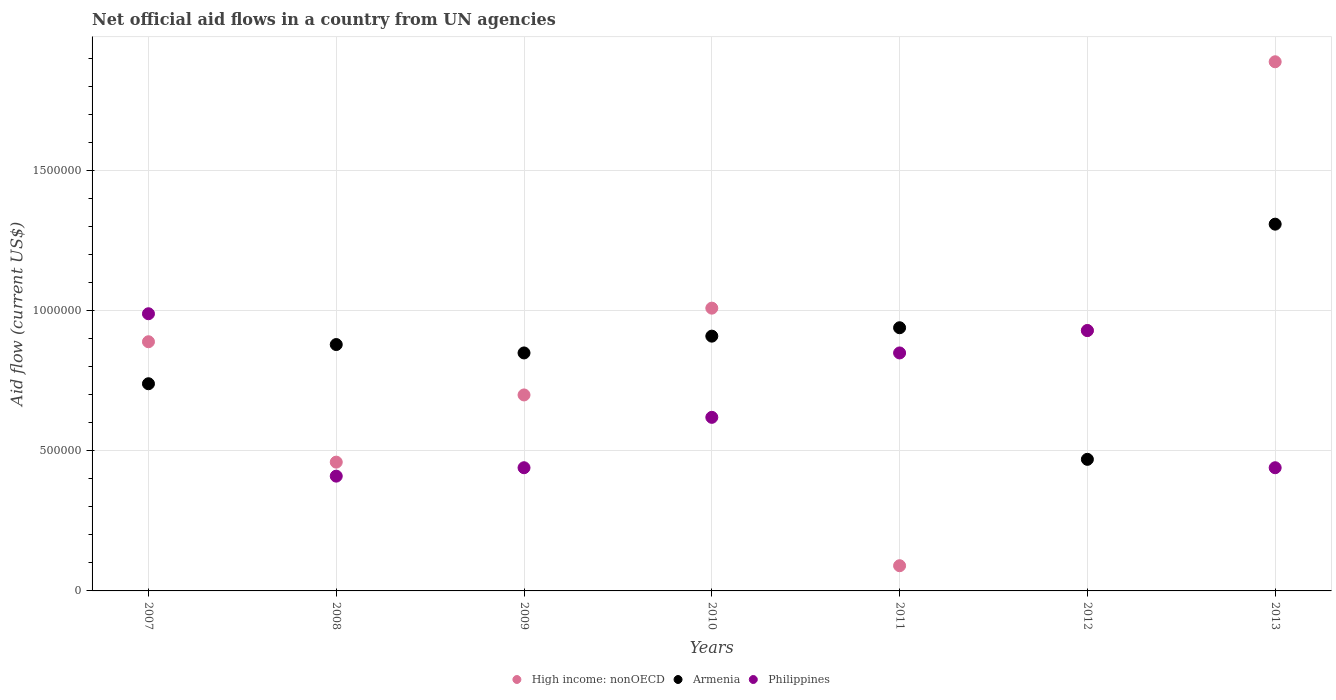How many different coloured dotlines are there?
Keep it short and to the point. 3. What is the net official aid flow in Armenia in 2009?
Give a very brief answer. 8.50e+05. Across all years, what is the maximum net official aid flow in Armenia?
Provide a succinct answer. 1.31e+06. Across all years, what is the minimum net official aid flow in High income: nonOECD?
Your response must be concise. 9.00e+04. In which year was the net official aid flow in Armenia minimum?
Provide a short and direct response. 2012. What is the total net official aid flow in High income: nonOECD in the graph?
Make the answer very short. 5.97e+06. What is the difference between the net official aid flow in Armenia in 2010 and that in 2013?
Your answer should be very brief. -4.00e+05. What is the difference between the net official aid flow in Philippines in 2011 and the net official aid flow in High income: nonOECD in 2009?
Provide a succinct answer. 1.50e+05. What is the average net official aid flow in High income: nonOECD per year?
Provide a short and direct response. 8.53e+05. In the year 2012, what is the difference between the net official aid flow in Philippines and net official aid flow in High income: nonOECD?
Your answer should be very brief. 0. What is the ratio of the net official aid flow in Philippines in 2008 to that in 2010?
Offer a terse response. 0.66. What is the difference between the highest and the second highest net official aid flow in Philippines?
Your answer should be compact. 6.00e+04. What is the difference between the highest and the lowest net official aid flow in High income: nonOECD?
Offer a terse response. 1.80e+06. In how many years, is the net official aid flow in Armenia greater than the average net official aid flow in Armenia taken over all years?
Provide a short and direct response. 4. Is the sum of the net official aid flow in High income: nonOECD in 2009 and 2010 greater than the maximum net official aid flow in Armenia across all years?
Offer a terse response. Yes. Is it the case that in every year, the sum of the net official aid flow in High income: nonOECD and net official aid flow in Philippines  is greater than the net official aid flow in Armenia?
Offer a very short reply. No. Is the net official aid flow in High income: nonOECD strictly greater than the net official aid flow in Armenia over the years?
Make the answer very short. No. Is the net official aid flow in High income: nonOECD strictly less than the net official aid flow in Philippines over the years?
Give a very brief answer. No. How many dotlines are there?
Your response must be concise. 3. What is the difference between two consecutive major ticks on the Y-axis?
Your response must be concise. 5.00e+05. Does the graph contain any zero values?
Ensure brevity in your answer.  No. Does the graph contain grids?
Your answer should be compact. Yes. Where does the legend appear in the graph?
Your answer should be compact. Bottom center. What is the title of the graph?
Provide a succinct answer. Net official aid flows in a country from UN agencies. Does "Macao" appear as one of the legend labels in the graph?
Offer a very short reply. No. What is the label or title of the X-axis?
Your response must be concise. Years. What is the label or title of the Y-axis?
Offer a terse response. Aid flow (current US$). What is the Aid flow (current US$) in High income: nonOECD in 2007?
Your answer should be very brief. 8.90e+05. What is the Aid flow (current US$) in Armenia in 2007?
Your answer should be very brief. 7.40e+05. What is the Aid flow (current US$) of Philippines in 2007?
Ensure brevity in your answer.  9.90e+05. What is the Aid flow (current US$) in Armenia in 2008?
Your answer should be compact. 8.80e+05. What is the Aid flow (current US$) of High income: nonOECD in 2009?
Your answer should be very brief. 7.00e+05. What is the Aid flow (current US$) of Armenia in 2009?
Offer a terse response. 8.50e+05. What is the Aid flow (current US$) in High income: nonOECD in 2010?
Keep it short and to the point. 1.01e+06. What is the Aid flow (current US$) of Armenia in 2010?
Your answer should be very brief. 9.10e+05. What is the Aid flow (current US$) of Philippines in 2010?
Provide a succinct answer. 6.20e+05. What is the Aid flow (current US$) in Armenia in 2011?
Keep it short and to the point. 9.40e+05. What is the Aid flow (current US$) of Philippines in 2011?
Make the answer very short. 8.50e+05. What is the Aid flow (current US$) in High income: nonOECD in 2012?
Provide a short and direct response. 9.30e+05. What is the Aid flow (current US$) in Philippines in 2012?
Provide a short and direct response. 9.30e+05. What is the Aid flow (current US$) in High income: nonOECD in 2013?
Provide a succinct answer. 1.89e+06. What is the Aid flow (current US$) in Armenia in 2013?
Keep it short and to the point. 1.31e+06. Across all years, what is the maximum Aid flow (current US$) in High income: nonOECD?
Provide a short and direct response. 1.89e+06. Across all years, what is the maximum Aid flow (current US$) of Armenia?
Offer a terse response. 1.31e+06. Across all years, what is the maximum Aid flow (current US$) in Philippines?
Your response must be concise. 9.90e+05. Across all years, what is the minimum Aid flow (current US$) of High income: nonOECD?
Offer a very short reply. 9.00e+04. Across all years, what is the minimum Aid flow (current US$) of Armenia?
Provide a succinct answer. 4.70e+05. Across all years, what is the minimum Aid flow (current US$) in Philippines?
Ensure brevity in your answer.  4.10e+05. What is the total Aid flow (current US$) of High income: nonOECD in the graph?
Make the answer very short. 5.97e+06. What is the total Aid flow (current US$) in Armenia in the graph?
Your response must be concise. 6.10e+06. What is the total Aid flow (current US$) of Philippines in the graph?
Ensure brevity in your answer.  4.68e+06. What is the difference between the Aid flow (current US$) in Philippines in 2007 and that in 2008?
Make the answer very short. 5.80e+05. What is the difference between the Aid flow (current US$) in Philippines in 2007 and that in 2009?
Make the answer very short. 5.50e+05. What is the difference between the Aid flow (current US$) of High income: nonOECD in 2007 and that in 2010?
Your answer should be compact. -1.20e+05. What is the difference between the Aid flow (current US$) in High income: nonOECD in 2007 and that in 2011?
Your response must be concise. 8.00e+05. What is the difference between the Aid flow (current US$) of Armenia in 2007 and that in 2012?
Make the answer very short. 2.70e+05. What is the difference between the Aid flow (current US$) of Philippines in 2007 and that in 2012?
Offer a terse response. 6.00e+04. What is the difference between the Aid flow (current US$) of Armenia in 2007 and that in 2013?
Give a very brief answer. -5.70e+05. What is the difference between the Aid flow (current US$) in Armenia in 2008 and that in 2009?
Provide a short and direct response. 3.00e+04. What is the difference between the Aid flow (current US$) of Philippines in 2008 and that in 2009?
Provide a short and direct response. -3.00e+04. What is the difference between the Aid flow (current US$) in High income: nonOECD in 2008 and that in 2010?
Offer a terse response. -5.50e+05. What is the difference between the Aid flow (current US$) of Armenia in 2008 and that in 2010?
Give a very brief answer. -3.00e+04. What is the difference between the Aid flow (current US$) in Philippines in 2008 and that in 2010?
Your response must be concise. -2.10e+05. What is the difference between the Aid flow (current US$) in Armenia in 2008 and that in 2011?
Your response must be concise. -6.00e+04. What is the difference between the Aid flow (current US$) of Philippines in 2008 and that in 2011?
Offer a terse response. -4.40e+05. What is the difference between the Aid flow (current US$) in High income: nonOECD in 2008 and that in 2012?
Give a very brief answer. -4.70e+05. What is the difference between the Aid flow (current US$) in Philippines in 2008 and that in 2012?
Provide a short and direct response. -5.20e+05. What is the difference between the Aid flow (current US$) of High income: nonOECD in 2008 and that in 2013?
Your answer should be very brief. -1.43e+06. What is the difference between the Aid flow (current US$) in Armenia in 2008 and that in 2013?
Make the answer very short. -4.30e+05. What is the difference between the Aid flow (current US$) of Philippines in 2008 and that in 2013?
Offer a terse response. -3.00e+04. What is the difference between the Aid flow (current US$) in High income: nonOECD in 2009 and that in 2010?
Provide a succinct answer. -3.10e+05. What is the difference between the Aid flow (current US$) in Armenia in 2009 and that in 2011?
Give a very brief answer. -9.00e+04. What is the difference between the Aid flow (current US$) in Philippines in 2009 and that in 2011?
Provide a short and direct response. -4.10e+05. What is the difference between the Aid flow (current US$) of High income: nonOECD in 2009 and that in 2012?
Make the answer very short. -2.30e+05. What is the difference between the Aid flow (current US$) of Armenia in 2009 and that in 2012?
Your response must be concise. 3.80e+05. What is the difference between the Aid flow (current US$) in Philippines in 2009 and that in 2012?
Provide a short and direct response. -4.90e+05. What is the difference between the Aid flow (current US$) in High income: nonOECD in 2009 and that in 2013?
Make the answer very short. -1.19e+06. What is the difference between the Aid flow (current US$) of Armenia in 2009 and that in 2013?
Your answer should be very brief. -4.60e+05. What is the difference between the Aid flow (current US$) of Philippines in 2009 and that in 2013?
Your answer should be very brief. 0. What is the difference between the Aid flow (current US$) of High income: nonOECD in 2010 and that in 2011?
Ensure brevity in your answer.  9.20e+05. What is the difference between the Aid flow (current US$) in Armenia in 2010 and that in 2011?
Provide a short and direct response. -3.00e+04. What is the difference between the Aid flow (current US$) of Philippines in 2010 and that in 2011?
Keep it short and to the point. -2.30e+05. What is the difference between the Aid flow (current US$) in High income: nonOECD in 2010 and that in 2012?
Your response must be concise. 8.00e+04. What is the difference between the Aid flow (current US$) in Philippines in 2010 and that in 2012?
Provide a succinct answer. -3.10e+05. What is the difference between the Aid flow (current US$) in High income: nonOECD in 2010 and that in 2013?
Provide a short and direct response. -8.80e+05. What is the difference between the Aid flow (current US$) of Armenia in 2010 and that in 2013?
Offer a terse response. -4.00e+05. What is the difference between the Aid flow (current US$) in Philippines in 2010 and that in 2013?
Provide a succinct answer. 1.80e+05. What is the difference between the Aid flow (current US$) of High income: nonOECD in 2011 and that in 2012?
Your answer should be compact. -8.40e+05. What is the difference between the Aid flow (current US$) of Armenia in 2011 and that in 2012?
Give a very brief answer. 4.70e+05. What is the difference between the Aid flow (current US$) of High income: nonOECD in 2011 and that in 2013?
Ensure brevity in your answer.  -1.80e+06. What is the difference between the Aid flow (current US$) in Armenia in 2011 and that in 2013?
Ensure brevity in your answer.  -3.70e+05. What is the difference between the Aid flow (current US$) of High income: nonOECD in 2012 and that in 2013?
Provide a short and direct response. -9.60e+05. What is the difference between the Aid flow (current US$) in Armenia in 2012 and that in 2013?
Your response must be concise. -8.40e+05. What is the difference between the Aid flow (current US$) of Armenia in 2007 and the Aid flow (current US$) of Philippines in 2008?
Keep it short and to the point. 3.30e+05. What is the difference between the Aid flow (current US$) of High income: nonOECD in 2007 and the Aid flow (current US$) of Armenia in 2009?
Provide a succinct answer. 4.00e+04. What is the difference between the Aid flow (current US$) in High income: nonOECD in 2007 and the Aid flow (current US$) in Philippines in 2009?
Your response must be concise. 4.50e+05. What is the difference between the Aid flow (current US$) of Armenia in 2007 and the Aid flow (current US$) of Philippines in 2009?
Ensure brevity in your answer.  3.00e+05. What is the difference between the Aid flow (current US$) of High income: nonOECD in 2007 and the Aid flow (current US$) of Armenia in 2010?
Offer a very short reply. -2.00e+04. What is the difference between the Aid flow (current US$) in High income: nonOECD in 2007 and the Aid flow (current US$) in Philippines in 2010?
Keep it short and to the point. 2.70e+05. What is the difference between the Aid flow (current US$) of Armenia in 2007 and the Aid flow (current US$) of Philippines in 2010?
Your response must be concise. 1.20e+05. What is the difference between the Aid flow (current US$) in Armenia in 2007 and the Aid flow (current US$) in Philippines in 2011?
Offer a terse response. -1.10e+05. What is the difference between the Aid flow (current US$) of High income: nonOECD in 2007 and the Aid flow (current US$) of Armenia in 2012?
Your answer should be compact. 4.20e+05. What is the difference between the Aid flow (current US$) in Armenia in 2007 and the Aid flow (current US$) in Philippines in 2012?
Keep it short and to the point. -1.90e+05. What is the difference between the Aid flow (current US$) of High income: nonOECD in 2007 and the Aid flow (current US$) of Armenia in 2013?
Give a very brief answer. -4.20e+05. What is the difference between the Aid flow (current US$) in High income: nonOECD in 2008 and the Aid flow (current US$) in Armenia in 2009?
Offer a very short reply. -3.90e+05. What is the difference between the Aid flow (current US$) in High income: nonOECD in 2008 and the Aid flow (current US$) in Philippines in 2009?
Ensure brevity in your answer.  2.00e+04. What is the difference between the Aid flow (current US$) in High income: nonOECD in 2008 and the Aid flow (current US$) in Armenia in 2010?
Provide a succinct answer. -4.50e+05. What is the difference between the Aid flow (current US$) in High income: nonOECD in 2008 and the Aid flow (current US$) in Philippines in 2010?
Offer a terse response. -1.60e+05. What is the difference between the Aid flow (current US$) in High income: nonOECD in 2008 and the Aid flow (current US$) in Armenia in 2011?
Provide a succinct answer. -4.80e+05. What is the difference between the Aid flow (current US$) of High income: nonOECD in 2008 and the Aid flow (current US$) of Philippines in 2011?
Give a very brief answer. -3.90e+05. What is the difference between the Aid flow (current US$) of Armenia in 2008 and the Aid flow (current US$) of Philippines in 2011?
Your answer should be compact. 3.00e+04. What is the difference between the Aid flow (current US$) of High income: nonOECD in 2008 and the Aid flow (current US$) of Philippines in 2012?
Make the answer very short. -4.70e+05. What is the difference between the Aid flow (current US$) in Armenia in 2008 and the Aid flow (current US$) in Philippines in 2012?
Offer a terse response. -5.00e+04. What is the difference between the Aid flow (current US$) in High income: nonOECD in 2008 and the Aid flow (current US$) in Armenia in 2013?
Your answer should be compact. -8.50e+05. What is the difference between the Aid flow (current US$) in High income: nonOECD in 2008 and the Aid flow (current US$) in Philippines in 2013?
Your answer should be very brief. 2.00e+04. What is the difference between the Aid flow (current US$) of High income: nonOECD in 2009 and the Aid flow (current US$) of Philippines in 2010?
Your answer should be compact. 8.00e+04. What is the difference between the Aid flow (current US$) in High income: nonOECD in 2009 and the Aid flow (current US$) in Armenia in 2011?
Offer a very short reply. -2.40e+05. What is the difference between the Aid flow (current US$) in High income: nonOECD in 2009 and the Aid flow (current US$) in Armenia in 2012?
Offer a very short reply. 2.30e+05. What is the difference between the Aid flow (current US$) of High income: nonOECD in 2009 and the Aid flow (current US$) of Armenia in 2013?
Provide a short and direct response. -6.10e+05. What is the difference between the Aid flow (current US$) in Armenia in 2009 and the Aid flow (current US$) in Philippines in 2013?
Ensure brevity in your answer.  4.10e+05. What is the difference between the Aid flow (current US$) in High income: nonOECD in 2010 and the Aid flow (current US$) in Philippines in 2011?
Ensure brevity in your answer.  1.60e+05. What is the difference between the Aid flow (current US$) of High income: nonOECD in 2010 and the Aid flow (current US$) of Armenia in 2012?
Offer a terse response. 5.40e+05. What is the difference between the Aid flow (current US$) in Armenia in 2010 and the Aid flow (current US$) in Philippines in 2012?
Keep it short and to the point. -2.00e+04. What is the difference between the Aid flow (current US$) in High income: nonOECD in 2010 and the Aid flow (current US$) in Armenia in 2013?
Offer a terse response. -3.00e+05. What is the difference between the Aid flow (current US$) in High income: nonOECD in 2010 and the Aid flow (current US$) in Philippines in 2013?
Offer a very short reply. 5.70e+05. What is the difference between the Aid flow (current US$) of Armenia in 2010 and the Aid flow (current US$) of Philippines in 2013?
Your answer should be compact. 4.70e+05. What is the difference between the Aid flow (current US$) in High income: nonOECD in 2011 and the Aid flow (current US$) in Armenia in 2012?
Ensure brevity in your answer.  -3.80e+05. What is the difference between the Aid flow (current US$) of High income: nonOECD in 2011 and the Aid flow (current US$) of Philippines in 2012?
Keep it short and to the point. -8.40e+05. What is the difference between the Aid flow (current US$) of Armenia in 2011 and the Aid flow (current US$) of Philippines in 2012?
Your response must be concise. 10000. What is the difference between the Aid flow (current US$) of High income: nonOECD in 2011 and the Aid flow (current US$) of Armenia in 2013?
Keep it short and to the point. -1.22e+06. What is the difference between the Aid flow (current US$) in High income: nonOECD in 2011 and the Aid flow (current US$) in Philippines in 2013?
Make the answer very short. -3.50e+05. What is the difference between the Aid flow (current US$) in High income: nonOECD in 2012 and the Aid flow (current US$) in Armenia in 2013?
Provide a short and direct response. -3.80e+05. What is the difference between the Aid flow (current US$) of Armenia in 2012 and the Aid flow (current US$) of Philippines in 2013?
Offer a very short reply. 3.00e+04. What is the average Aid flow (current US$) in High income: nonOECD per year?
Ensure brevity in your answer.  8.53e+05. What is the average Aid flow (current US$) in Armenia per year?
Provide a succinct answer. 8.71e+05. What is the average Aid flow (current US$) of Philippines per year?
Ensure brevity in your answer.  6.69e+05. In the year 2007, what is the difference between the Aid flow (current US$) in High income: nonOECD and Aid flow (current US$) in Armenia?
Make the answer very short. 1.50e+05. In the year 2008, what is the difference between the Aid flow (current US$) of High income: nonOECD and Aid flow (current US$) of Armenia?
Give a very brief answer. -4.20e+05. In the year 2009, what is the difference between the Aid flow (current US$) of High income: nonOECD and Aid flow (current US$) of Armenia?
Provide a succinct answer. -1.50e+05. In the year 2009, what is the difference between the Aid flow (current US$) of High income: nonOECD and Aid flow (current US$) of Philippines?
Offer a very short reply. 2.60e+05. In the year 2009, what is the difference between the Aid flow (current US$) in Armenia and Aid flow (current US$) in Philippines?
Your response must be concise. 4.10e+05. In the year 2010, what is the difference between the Aid flow (current US$) in Armenia and Aid flow (current US$) in Philippines?
Ensure brevity in your answer.  2.90e+05. In the year 2011, what is the difference between the Aid flow (current US$) in High income: nonOECD and Aid flow (current US$) in Armenia?
Your response must be concise. -8.50e+05. In the year 2011, what is the difference between the Aid flow (current US$) of High income: nonOECD and Aid flow (current US$) of Philippines?
Make the answer very short. -7.60e+05. In the year 2012, what is the difference between the Aid flow (current US$) in High income: nonOECD and Aid flow (current US$) in Armenia?
Provide a succinct answer. 4.60e+05. In the year 2012, what is the difference between the Aid flow (current US$) in Armenia and Aid flow (current US$) in Philippines?
Provide a succinct answer. -4.60e+05. In the year 2013, what is the difference between the Aid flow (current US$) of High income: nonOECD and Aid flow (current US$) of Armenia?
Keep it short and to the point. 5.80e+05. In the year 2013, what is the difference between the Aid flow (current US$) in High income: nonOECD and Aid flow (current US$) in Philippines?
Make the answer very short. 1.45e+06. In the year 2013, what is the difference between the Aid flow (current US$) of Armenia and Aid flow (current US$) of Philippines?
Your response must be concise. 8.70e+05. What is the ratio of the Aid flow (current US$) of High income: nonOECD in 2007 to that in 2008?
Provide a short and direct response. 1.93. What is the ratio of the Aid flow (current US$) in Armenia in 2007 to that in 2008?
Offer a terse response. 0.84. What is the ratio of the Aid flow (current US$) of Philippines in 2007 to that in 2008?
Your answer should be compact. 2.41. What is the ratio of the Aid flow (current US$) in High income: nonOECD in 2007 to that in 2009?
Provide a succinct answer. 1.27. What is the ratio of the Aid flow (current US$) of Armenia in 2007 to that in 2009?
Ensure brevity in your answer.  0.87. What is the ratio of the Aid flow (current US$) of Philippines in 2007 to that in 2009?
Provide a succinct answer. 2.25. What is the ratio of the Aid flow (current US$) in High income: nonOECD in 2007 to that in 2010?
Your answer should be compact. 0.88. What is the ratio of the Aid flow (current US$) of Armenia in 2007 to that in 2010?
Your response must be concise. 0.81. What is the ratio of the Aid flow (current US$) in Philippines in 2007 to that in 2010?
Your response must be concise. 1.6. What is the ratio of the Aid flow (current US$) of High income: nonOECD in 2007 to that in 2011?
Offer a very short reply. 9.89. What is the ratio of the Aid flow (current US$) of Armenia in 2007 to that in 2011?
Offer a terse response. 0.79. What is the ratio of the Aid flow (current US$) of Philippines in 2007 to that in 2011?
Ensure brevity in your answer.  1.16. What is the ratio of the Aid flow (current US$) in Armenia in 2007 to that in 2012?
Keep it short and to the point. 1.57. What is the ratio of the Aid flow (current US$) in Philippines in 2007 to that in 2012?
Offer a very short reply. 1.06. What is the ratio of the Aid flow (current US$) of High income: nonOECD in 2007 to that in 2013?
Offer a very short reply. 0.47. What is the ratio of the Aid flow (current US$) in Armenia in 2007 to that in 2013?
Offer a very short reply. 0.56. What is the ratio of the Aid flow (current US$) of Philippines in 2007 to that in 2013?
Provide a short and direct response. 2.25. What is the ratio of the Aid flow (current US$) of High income: nonOECD in 2008 to that in 2009?
Ensure brevity in your answer.  0.66. What is the ratio of the Aid flow (current US$) in Armenia in 2008 to that in 2009?
Ensure brevity in your answer.  1.04. What is the ratio of the Aid flow (current US$) of Philippines in 2008 to that in 2009?
Provide a short and direct response. 0.93. What is the ratio of the Aid flow (current US$) in High income: nonOECD in 2008 to that in 2010?
Keep it short and to the point. 0.46. What is the ratio of the Aid flow (current US$) of Armenia in 2008 to that in 2010?
Offer a very short reply. 0.97. What is the ratio of the Aid flow (current US$) in Philippines in 2008 to that in 2010?
Ensure brevity in your answer.  0.66. What is the ratio of the Aid flow (current US$) of High income: nonOECD in 2008 to that in 2011?
Your response must be concise. 5.11. What is the ratio of the Aid flow (current US$) in Armenia in 2008 to that in 2011?
Ensure brevity in your answer.  0.94. What is the ratio of the Aid flow (current US$) of Philippines in 2008 to that in 2011?
Your response must be concise. 0.48. What is the ratio of the Aid flow (current US$) in High income: nonOECD in 2008 to that in 2012?
Your response must be concise. 0.49. What is the ratio of the Aid flow (current US$) of Armenia in 2008 to that in 2012?
Your answer should be compact. 1.87. What is the ratio of the Aid flow (current US$) of Philippines in 2008 to that in 2012?
Ensure brevity in your answer.  0.44. What is the ratio of the Aid flow (current US$) in High income: nonOECD in 2008 to that in 2013?
Offer a very short reply. 0.24. What is the ratio of the Aid flow (current US$) in Armenia in 2008 to that in 2013?
Provide a short and direct response. 0.67. What is the ratio of the Aid flow (current US$) in Philippines in 2008 to that in 2013?
Provide a succinct answer. 0.93. What is the ratio of the Aid flow (current US$) of High income: nonOECD in 2009 to that in 2010?
Make the answer very short. 0.69. What is the ratio of the Aid flow (current US$) of Armenia in 2009 to that in 2010?
Offer a terse response. 0.93. What is the ratio of the Aid flow (current US$) in Philippines in 2009 to that in 2010?
Provide a succinct answer. 0.71. What is the ratio of the Aid flow (current US$) in High income: nonOECD in 2009 to that in 2011?
Ensure brevity in your answer.  7.78. What is the ratio of the Aid flow (current US$) in Armenia in 2009 to that in 2011?
Give a very brief answer. 0.9. What is the ratio of the Aid flow (current US$) of Philippines in 2009 to that in 2011?
Your answer should be compact. 0.52. What is the ratio of the Aid flow (current US$) in High income: nonOECD in 2009 to that in 2012?
Keep it short and to the point. 0.75. What is the ratio of the Aid flow (current US$) of Armenia in 2009 to that in 2012?
Offer a very short reply. 1.81. What is the ratio of the Aid flow (current US$) in Philippines in 2009 to that in 2012?
Provide a succinct answer. 0.47. What is the ratio of the Aid flow (current US$) in High income: nonOECD in 2009 to that in 2013?
Your answer should be very brief. 0.37. What is the ratio of the Aid flow (current US$) in Armenia in 2009 to that in 2013?
Provide a short and direct response. 0.65. What is the ratio of the Aid flow (current US$) of Philippines in 2009 to that in 2013?
Ensure brevity in your answer.  1. What is the ratio of the Aid flow (current US$) in High income: nonOECD in 2010 to that in 2011?
Your answer should be very brief. 11.22. What is the ratio of the Aid flow (current US$) in Armenia in 2010 to that in 2011?
Keep it short and to the point. 0.97. What is the ratio of the Aid flow (current US$) in Philippines in 2010 to that in 2011?
Provide a short and direct response. 0.73. What is the ratio of the Aid flow (current US$) of High income: nonOECD in 2010 to that in 2012?
Ensure brevity in your answer.  1.09. What is the ratio of the Aid flow (current US$) of Armenia in 2010 to that in 2012?
Provide a short and direct response. 1.94. What is the ratio of the Aid flow (current US$) of Philippines in 2010 to that in 2012?
Your response must be concise. 0.67. What is the ratio of the Aid flow (current US$) in High income: nonOECD in 2010 to that in 2013?
Provide a short and direct response. 0.53. What is the ratio of the Aid flow (current US$) of Armenia in 2010 to that in 2013?
Your response must be concise. 0.69. What is the ratio of the Aid flow (current US$) in Philippines in 2010 to that in 2013?
Keep it short and to the point. 1.41. What is the ratio of the Aid flow (current US$) of High income: nonOECD in 2011 to that in 2012?
Your response must be concise. 0.1. What is the ratio of the Aid flow (current US$) of Philippines in 2011 to that in 2012?
Offer a terse response. 0.91. What is the ratio of the Aid flow (current US$) in High income: nonOECD in 2011 to that in 2013?
Make the answer very short. 0.05. What is the ratio of the Aid flow (current US$) of Armenia in 2011 to that in 2013?
Your response must be concise. 0.72. What is the ratio of the Aid flow (current US$) in Philippines in 2011 to that in 2013?
Keep it short and to the point. 1.93. What is the ratio of the Aid flow (current US$) in High income: nonOECD in 2012 to that in 2013?
Your response must be concise. 0.49. What is the ratio of the Aid flow (current US$) in Armenia in 2012 to that in 2013?
Make the answer very short. 0.36. What is the ratio of the Aid flow (current US$) of Philippines in 2012 to that in 2013?
Ensure brevity in your answer.  2.11. What is the difference between the highest and the second highest Aid flow (current US$) of High income: nonOECD?
Your answer should be compact. 8.80e+05. What is the difference between the highest and the second highest Aid flow (current US$) in Armenia?
Ensure brevity in your answer.  3.70e+05. What is the difference between the highest and the second highest Aid flow (current US$) in Philippines?
Your answer should be compact. 6.00e+04. What is the difference between the highest and the lowest Aid flow (current US$) of High income: nonOECD?
Your response must be concise. 1.80e+06. What is the difference between the highest and the lowest Aid flow (current US$) of Armenia?
Offer a terse response. 8.40e+05. What is the difference between the highest and the lowest Aid flow (current US$) of Philippines?
Provide a succinct answer. 5.80e+05. 